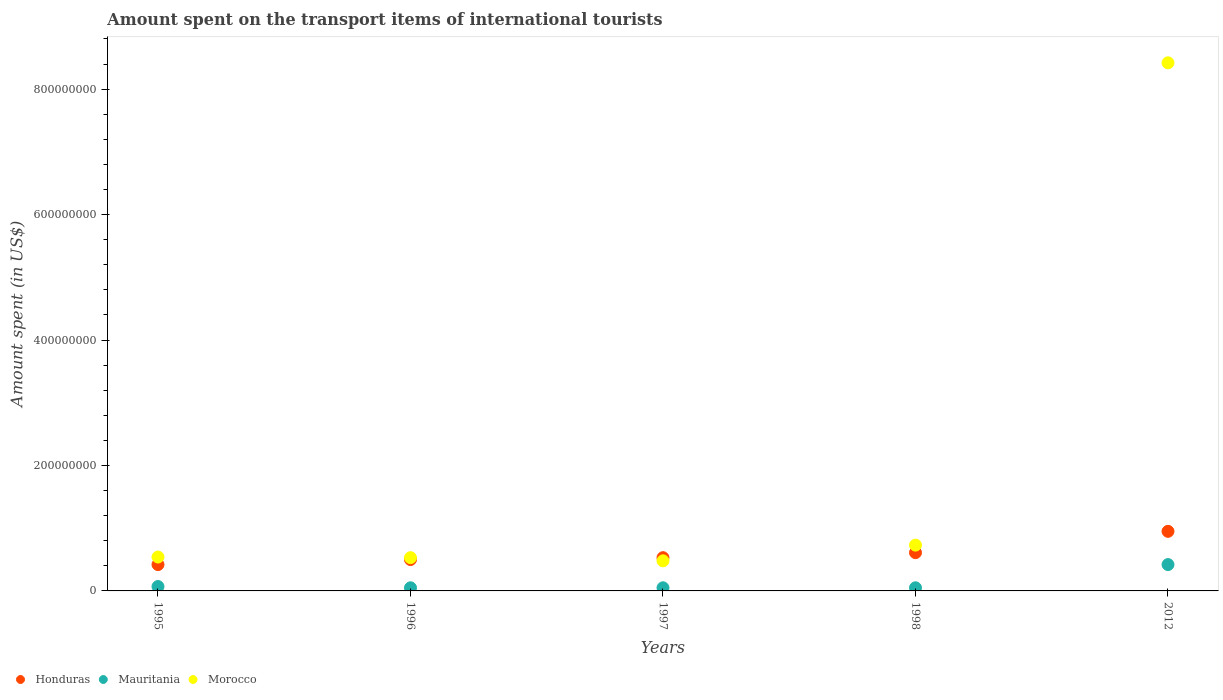How many different coloured dotlines are there?
Provide a succinct answer. 3. What is the amount spent on the transport items of international tourists in Mauritania in 1997?
Provide a succinct answer. 5.00e+06. Across all years, what is the maximum amount spent on the transport items of international tourists in Honduras?
Give a very brief answer. 9.50e+07. Across all years, what is the minimum amount spent on the transport items of international tourists in Honduras?
Offer a terse response. 4.20e+07. In which year was the amount spent on the transport items of international tourists in Honduras maximum?
Keep it short and to the point. 2012. What is the total amount spent on the transport items of international tourists in Mauritania in the graph?
Your response must be concise. 6.40e+07. What is the difference between the amount spent on the transport items of international tourists in Morocco in 1995 and that in 1998?
Make the answer very short. -1.90e+07. What is the difference between the amount spent on the transport items of international tourists in Honduras in 1998 and the amount spent on the transport items of international tourists in Morocco in 1997?
Make the answer very short. 1.30e+07. What is the average amount spent on the transport items of international tourists in Mauritania per year?
Offer a terse response. 1.28e+07. In the year 1997, what is the difference between the amount spent on the transport items of international tourists in Mauritania and amount spent on the transport items of international tourists in Morocco?
Ensure brevity in your answer.  -4.30e+07. Is the amount spent on the transport items of international tourists in Morocco in 1995 less than that in 2012?
Provide a short and direct response. Yes. Is the difference between the amount spent on the transport items of international tourists in Mauritania in 1996 and 2012 greater than the difference between the amount spent on the transport items of international tourists in Morocco in 1996 and 2012?
Provide a succinct answer. Yes. What is the difference between the highest and the second highest amount spent on the transport items of international tourists in Honduras?
Provide a short and direct response. 3.40e+07. What is the difference between the highest and the lowest amount spent on the transport items of international tourists in Mauritania?
Keep it short and to the point. 3.70e+07. In how many years, is the amount spent on the transport items of international tourists in Morocco greater than the average amount spent on the transport items of international tourists in Morocco taken over all years?
Make the answer very short. 1. Is the sum of the amount spent on the transport items of international tourists in Mauritania in 1996 and 2012 greater than the maximum amount spent on the transport items of international tourists in Morocco across all years?
Offer a very short reply. No. Is it the case that in every year, the sum of the amount spent on the transport items of international tourists in Honduras and amount spent on the transport items of international tourists in Mauritania  is greater than the amount spent on the transport items of international tourists in Morocco?
Keep it short and to the point. No. Does the amount spent on the transport items of international tourists in Honduras monotonically increase over the years?
Keep it short and to the point. Yes. Is the amount spent on the transport items of international tourists in Morocco strictly greater than the amount spent on the transport items of international tourists in Honduras over the years?
Ensure brevity in your answer.  No. Where does the legend appear in the graph?
Make the answer very short. Bottom left. How many legend labels are there?
Your answer should be compact. 3. What is the title of the graph?
Give a very brief answer. Amount spent on the transport items of international tourists. Does "Guam" appear as one of the legend labels in the graph?
Offer a very short reply. No. What is the label or title of the Y-axis?
Make the answer very short. Amount spent (in US$). What is the Amount spent (in US$) of Honduras in 1995?
Ensure brevity in your answer.  4.20e+07. What is the Amount spent (in US$) in Morocco in 1995?
Provide a succinct answer. 5.40e+07. What is the Amount spent (in US$) of Honduras in 1996?
Your answer should be compact. 5.00e+07. What is the Amount spent (in US$) of Morocco in 1996?
Offer a very short reply. 5.30e+07. What is the Amount spent (in US$) in Honduras in 1997?
Give a very brief answer. 5.30e+07. What is the Amount spent (in US$) in Morocco in 1997?
Your answer should be compact. 4.80e+07. What is the Amount spent (in US$) in Honduras in 1998?
Make the answer very short. 6.10e+07. What is the Amount spent (in US$) in Morocco in 1998?
Offer a very short reply. 7.30e+07. What is the Amount spent (in US$) of Honduras in 2012?
Offer a terse response. 9.50e+07. What is the Amount spent (in US$) in Mauritania in 2012?
Make the answer very short. 4.20e+07. What is the Amount spent (in US$) of Morocco in 2012?
Your response must be concise. 8.42e+08. Across all years, what is the maximum Amount spent (in US$) in Honduras?
Your response must be concise. 9.50e+07. Across all years, what is the maximum Amount spent (in US$) of Mauritania?
Offer a very short reply. 4.20e+07. Across all years, what is the maximum Amount spent (in US$) in Morocco?
Keep it short and to the point. 8.42e+08. Across all years, what is the minimum Amount spent (in US$) of Honduras?
Your answer should be compact. 4.20e+07. Across all years, what is the minimum Amount spent (in US$) in Mauritania?
Give a very brief answer. 5.00e+06. Across all years, what is the minimum Amount spent (in US$) in Morocco?
Your response must be concise. 4.80e+07. What is the total Amount spent (in US$) of Honduras in the graph?
Your answer should be very brief. 3.01e+08. What is the total Amount spent (in US$) of Mauritania in the graph?
Provide a succinct answer. 6.40e+07. What is the total Amount spent (in US$) in Morocco in the graph?
Your response must be concise. 1.07e+09. What is the difference between the Amount spent (in US$) in Honduras in 1995 and that in 1996?
Provide a succinct answer. -8.00e+06. What is the difference between the Amount spent (in US$) in Morocco in 1995 and that in 1996?
Ensure brevity in your answer.  1.00e+06. What is the difference between the Amount spent (in US$) of Honduras in 1995 and that in 1997?
Ensure brevity in your answer.  -1.10e+07. What is the difference between the Amount spent (in US$) of Honduras in 1995 and that in 1998?
Your answer should be compact. -1.90e+07. What is the difference between the Amount spent (in US$) in Mauritania in 1995 and that in 1998?
Your answer should be very brief. 2.00e+06. What is the difference between the Amount spent (in US$) of Morocco in 1995 and that in 1998?
Offer a terse response. -1.90e+07. What is the difference between the Amount spent (in US$) of Honduras in 1995 and that in 2012?
Offer a very short reply. -5.30e+07. What is the difference between the Amount spent (in US$) of Mauritania in 1995 and that in 2012?
Offer a very short reply. -3.50e+07. What is the difference between the Amount spent (in US$) in Morocco in 1995 and that in 2012?
Keep it short and to the point. -7.88e+08. What is the difference between the Amount spent (in US$) in Mauritania in 1996 and that in 1997?
Give a very brief answer. 0. What is the difference between the Amount spent (in US$) in Honduras in 1996 and that in 1998?
Give a very brief answer. -1.10e+07. What is the difference between the Amount spent (in US$) in Morocco in 1996 and that in 1998?
Your answer should be compact. -2.00e+07. What is the difference between the Amount spent (in US$) of Honduras in 1996 and that in 2012?
Make the answer very short. -4.50e+07. What is the difference between the Amount spent (in US$) of Mauritania in 1996 and that in 2012?
Provide a succinct answer. -3.70e+07. What is the difference between the Amount spent (in US$) in Morocco in 1996 and that in 2012?
Ensure brevity in your answer.  -7.89e+08. What is the difference between the Amount spent (in US$) of Honduras in 1997 and that in 1998?
Your response must be concise. -8.00e+06. What is the difference between the Amount spent (in US$) in Mauritania in 1997 and that in 1998?
Offer a terse response. 0. What is the difference between the Amount spent (in US$) of Morocco in 1997 and that in 1998?
Make the answer very short. -2.50e+07. What is the difference between the Amount spent (in US$) of Honduras in 1997 and that in 2012?
Make the answer very short. -4.20e+07. What is the difference between the Amount spent (in US$) of Mauritania in 1997 and that in 2012?
Your answer should be very brief. -3.70e+07. What is the difference between the Amount spent (in US$) in Morocco in 1997 and that in 2012?
Offer a very short reply. -7.94e+08. What is the difference between the Amount spent (in US$) of Honduras in 1998 and that in 2012?
Provide a succinct answer. -3.40e+07. What is the difference between the Amount spent (in US$) in Mauritania in 1998 and that in 2012?
Your answer should be very brief. -3.70e+07. What is the difference between the Amount spent (in US$) in Morocco in 1998 and that in 2012?
Provide a short and direct response. -7.69e+08. What is the difference between the Amount spent (in US$) in Honduras in 1995 and the Amount spent (in US$) in Mauritania in 1996?
Provide a short and direct response. 3.70e+07. What is the difference between the Amount spent (in US$) of Honduras in 1995 and the Amount spent (in US$) of Morocco in 1996?
Offer a very short reply. -1.10e+07. What is the difference between the Amount spent (in US$) in Mauritania in 1995 and the Amount spent (in US$) in Morocco in 1996?
Provide a succinct answer. -4.60e+07. What is the difference between the Amount spent (in US$) of Honduras in 1995 and the Amount spent (in US$) of Mauritania in 1997?
Offer a very short reply. 3.70e+07. What is the difference between the Amount spent (in US$) in Honduras in 1995 and the Amount spent (in US$) in Morocco in 1997?
Give a very brief answer. -6.00e+06. What is the difference between the Amount spent (in US$) in Mauritania in 1995 and the Amount spent (in US$) in Morocco in 1997?
Offer a terse response. -4.10e+07. What is the difference between the Amount spent (in US$) in Honduras in 1995 and the Amount spent (in US$) in Mauritania in 1998?
Your answer should be very brief. 3.70e+07. What is the difference between the Amount spent (in US$) of Honduras in 1995 and the Amount spent (in US$) of Morocco in 1998?
Give a very brief answer. -3.10e+07. What is the difference between the Amount spent (in US$) in Mauritania in 1995 and the Amount spent (in US$) in Morocco in 1998?
Your answer should be very brief. -6.60e+07. What is the difference between the Amount spent (in US$) in Honduras in 1995 and the Amount spent (in US$) in Mauritania in 2012?
Your answer should be very brief. 0. What is the difference between the Amount spent (in US$) in Honduras in 1995 and the Amount spent (in US$) in Morocco in 2012?
Your answer should be very brief. -8.00e+08. What is the difference between the Amount spent (in US$) in Mauritania in 1995 and the Amount spent (in US$) in Morocco in 2012?
Ensure brevity in your answer.  -8.35e+08. What is the difference between the Amount spent (in US$) of Honduras in 1996 and the Amount spent (in US$) of Mauritania in 1997?
Keep it short and to the point. 4.50e+07. What is the difference between the Amount spent (in US$) of Mauritania in 1996 and the Amount spent (in US$) of Morocco in 1997?
Offer a terse response. -4.30e+07. What is the difference between the Amount spent (in US$) in Honduras in 1996 and the Amount spent (in US$) in Mauritania in 1998?
Your answer should be compact. 4.50e+07. What is the difference between the Amount spent (in US$) of Honduras in 1996 and the Amount spent (in US$) of Morocco in 1998?
Provide a short and direct response. -2.30e+07. What is the difference between the Amount spent (in US$) in Mauritania in 1996 and the Amount spent (in US$) in Morocco in 1998?
Provide a short and direct response. -6.80e+07. What is the difference between the Amount spent (in US$) of Honduras in 1996 and the Amount spent (in US$) of Morocco in 2012?
Ensure brevity in your answer.  -7.92e+08. What is the difference between the Amount spent (in US$) in Mauritania in 1996 and the Amount spent (in US$) in Morocco in 2012?
Provide a short and direct response. -8.37e+08. What is the difference between the Amount spent (in US$) in Honduras in 1997 and the Amount spent (in US$) in Mauritania in 1998?
Provide a succinct answer. 4.80e+07. What is the difference between the Amount spent (in US$) in Honduras in 1997 and the Amount spent (in US$) in Morocco in 1998?
Your answer should be compact. -2.00e+07. What is the difference between the Amount spent (in US$) in Mauritania in 1997 and the Amount spent (in US$) in Morocco in 1998?
Provide a short and direct response. -6.80e+07. What is the difference between the Amount spent (in US$) in Honduras in 1997 and the Amount spent (in US$) in Mauritania in 2012?
Offer a very short reply. 1.10e+07. What is the difference between the Amount spent (in US$) of Honduras in 1997 and the Amount spent (in US$) of Morocco in 2012?
Give a very brief answer. -7.89e+08. What is the difference between the Amount spent (in US$) in Mauritania in 1997 and the Amount spent (in US$) in Morocco in 2012?
Your response must be concise. -8.37e+08. What is the difference between the Amount spent (in US$) of Honduras in 1998 and the Amount spent (in US$) of Mauritania in 2012?
Keep it short and to the point. 1.90e+07. What is the difference between the Amount spent (in US$) in Honduras in 1998 and the Amount spent (in US$) in Morocco in 2012?
Keep it short and to the point. -7.81e+08. What is the difference between the Amount spent (in US$) in Mauritania in 1998 and the Amount spent (in US$) in Morocco in 2012?
Make the answer very short. -8.37e+08. What is the average Amount spent (in US$) of Honduras per year?
Offer a terse response. 6.02e+07. What is the average Amount spent (in US$) in Mauritania per year?
Provide a succinct answer. 1.28e+07. What is the average Amount spent (in US$) in Morocco per year?
Make the answer very short. 2.14e+08. In the year 1995, what is the difference between the Amount spent (in US$) of Honduras and Amount spent (in US$) of Mauritania?
Provide a short and direct response. 3.50e+07. In the year 1995, what is the difference between the Amount spent (in US$) of Honduras and Amount spent (in US$) of Morocco?
Your answer should be very brief. -1.20e+07. In the year 1995, what is the difference between the Amount spent (in US$) of Mauritania and Amount spent (in US$) of Morocco?
Your answer should be very brief. -4.70e+07. In the year 1996, what is the difference between the Amount spent (in US$) of Honduras and Amount spent (in US$) of Mauritania?
Provide a short and direct response. 4.50e+07. In the year 1996, what is the difference between the Amount spent (in US$) of Honduras and Amount spent (in US$) of Morocco?
Your answer should be compact. -3.00e+06. In the year 1996, what is the difference between the Amount spent (in US$) of Mauritania and Amount spent (in US$) of Morocco?
Your answer should be compact. -4.80e+07. In the year 1997, what is the difference between the Amount spent (in US$) of Honduras and Amount spent (in US$) of Mauritania?
Give a very brief answer. 4.80e+07. In the year 1997, what is the difference between the Amount spent (in US$) of Honduras and Amount spent (in US$) of Morocco?
Your answer should be compact. 5.00e+06. In the year 1997, what is the difference between the Amount spent (in US$) of Mauritania and Amount spent (in US$) of Morocco?
Your answer should be compact. -4.30e+07. In the year 1998, what is the difference between the Amount spent (in US$) of Honduras and Amount spent (in US$) of Mauritania?
Provide a short and direct response. 5.60e+07. In the year 1998, what is the difference between the Amount spent (in US$) of Honduras and Amount spent (in US$) of Morocco?
Provide a short and direct response. -1.20e+07. In the year 1998, what is the difference between the Amount spent (in US$) in Mauritania and Amount spent (in US$) in Morocco?
Offer a terse response. -6.80e+07. In the year 2012, what is the difference between the Amount spent (in US$) in Honduras and Amount spent (in US$) in Mauritania?
Offer a very short reply. 5.30e+07. In the year 2012, what is the difference between the Amount spent (in US$) of Honduras and Amount spent (in US$) of Morocco?
Offer a very short reply. -7.47e+08. In the year 2012, what is the difference between the Amount spent (in US$) in Mauritania and Amount spent (in US$) in Morocco?
Provide a short and direct response. -8.00e+08. What is the ratio of the Amount spent (in US$) in Honduras in 1995 to that in 1996?
Give a very brief answer. 0.84. What is the ratio of the Amount spent (in US$) of Morocco in 1995 to that in 1996?
Keep it short and to the point. 1.02. What is the ratio of the Amount spent (in US$) in Honduras in 1995 to that in 1997?
Give a very brief answer. 0.79. What is the ratio of the Amount spent (in US$) of Mauritania in 1995 to that in 1997?
Ensure brevity in your answer.  1.4. What is the ratio of the Amount spent (in US$) of Honduras in 1995 to that in 1998?
Offer a terse response. 0.69. What is the ratio of the Amount spent (in US$) in Mauritania in 1995 to that in 1998?
Give a very brief answer. 1.4. What is the ratio of the Amount spent (in US$) in Morocco in 1995 to that in 1998?
Provide a succinct answer. 0.74. What is the ratio of the Amount spent (in US$) of Honduras in 1995 to that in 2012?
Provide a succinct answer. 0.44. What is the ratio of the Amount spent (in US$) of Mauritania in 1995 to that in 2012?
Your answer should be very brief. 0.17. What is the ratio of the Amount spent (in US$) in Morocco in 1995 to that in 2012?
Offer a very short reply. 0.06. What is the ratio of the Amount spent (in US$) in Honduras in 1996 to that in 1997?
Provide a short and direct response. 0.94. What is the ratio of the Amount spent (in US$) of Morocco in 1996 to that in 1997?
Your response must be concise. 1.1. What is the ratio of the Amount spent (in US$) in Honduras in 1996 to that in 1998?
Make the answer very short. 0.82. What is the ratio of the Amount spent (in US$) of Morocco in 1996 to that in 1998?
Your answer should be very brief. 0.73. What is the ratio of the Amount spent (in US$) in Honduras in 1996 to that in 2012?
Offer a terse response. 0.53. What is the ratio of the Amount spent (in US$) of Mauritania in 1996 to that in 2012?
Offer a very short reply. 0.12. What is the ratio of the Amount spent (in US$) in Morocco in 1996 to that in 2012?
Provide a short and direct response. 0.06. What is the ratio of the Amount spent (in US$) in Honduras in 1997 to that in 1998?
Ensure brevity in your answer.  0.87. What is the ratio of the Amount spent (in US$) of Morocco in 1997 to that in 1998?
Give a very brief answer. 0.66. What is the ratio of the Amount spent (in US$) of Honduras in 1997 to that in 2012?
Offer a terse response. 0.56. What is the ratio of the Amount spent (in US$) of Mauritania in 1997 to that in 2012?
Offer a terse response. 0.12. What is the ratio of the Amount spent (in US$) of Morocco in 1997 to that in 2012?
Ensure brevity in your answer.  0.06. What is the ratio of the Amount spent (in US$) in Honduras in 1998 to that in 2012?
Give a very brief answer. 0.64. What is the ratio of the Amount spent (in US$) in Mauritania in 1998 to that in 2012?
Make the answer very short. 0.12. What is the ratio of the Amount spent (in US$) of Morocco in 1998 to that in 2012?
Your answer should be compact. 0.09. What is the difference between the highest and the second highest Amount spent (in US$) of Honduras?
Offer a terse response. 3.40e+07. What is the difference between the highest and the second highest Amount spent (in US$) of Mauritania?
Provide a short and direct response. 3.50e+07. What is the difference between the highest and the second highest Amount spent (in US$) of Morocco?
Make the answer very short. 7.69e+08. What is the difference between the highest and the lowest Amount spent (in US$) in Honduras?
Keep it short and to the point. 5.30e+07. What is the difference between the highest and the lowest Amount spent (in US$) of Mauritania?
Your answer should be very brief. 3.70e+07. What is the difference between the highest and the lowest Amount spent (in US$) in Morocco?
Your answer should be compact. 7.94e+08. 